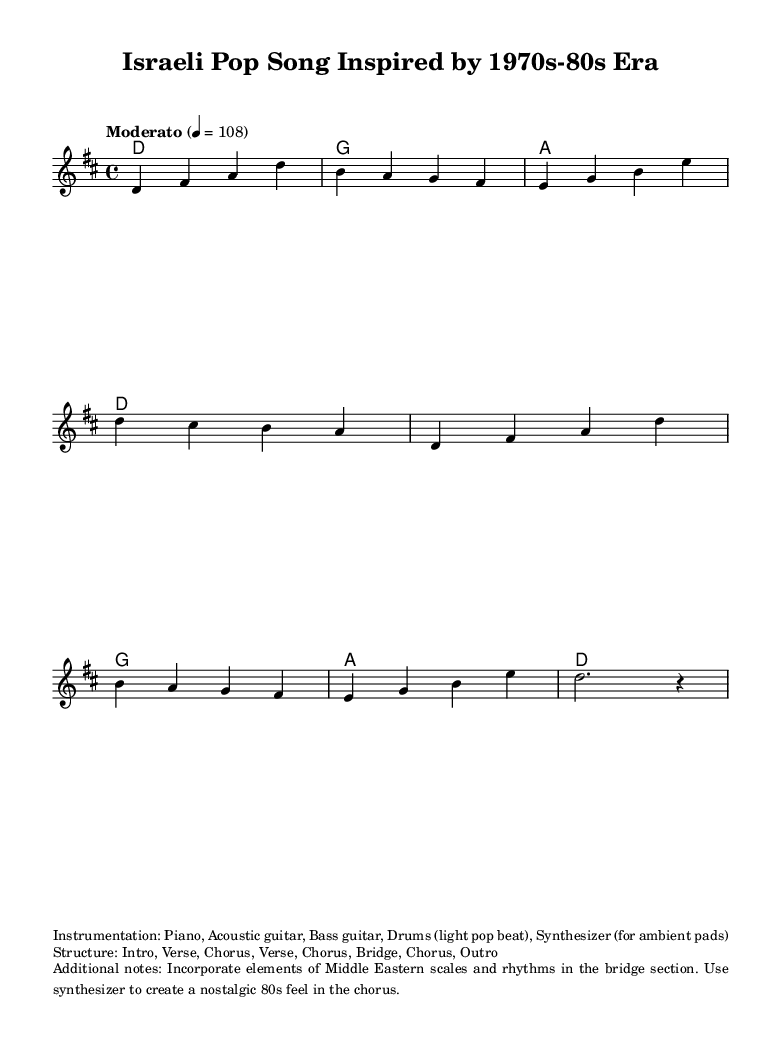What is the key signature of this music? The key signature is D major, which has two sharps (F# and C#). This can be determined by looking at the key signature notations at the beginning of the music.
Answer: D major What is the time signature of the music? The time signature is 4/4, which indicates that there are four beats in each measure and the quarter note receives one beat. This is shown at the beginning of the score.
Answer: 4/4 What is the tempo marking given in the sheet music? The tempo marking is 'Moderato,' indicating a moderate speed, and it is set at 108 beats per minute. This tempo indicator is usually found at the start of the score.
Answer: Moderato How many sections are there in the song structure? The song structure includes Intro, Verse, Chorus, Verse, Chorus, Bridge, Chorus, and Outro, which results in a total of eight sections. This structure is detailed in the provided markup notes.
Answer: Eight What instruments are included in the instrumentation? The instrumentation includes Piano, Acoustic guitar, Bass guitar, Drums, and Synthesizer. This information is listed under the additional notes portion of the score.
Answer: Piano, Acoustic guitar, Bass guitar, Drums, Synthesizer What is the first chord of the piece? The first chord of the piece is D major, as specified in the chord progression at the beginning of the score. This can be determined by looking at the first measure of the harmonies section.
Answer: D 